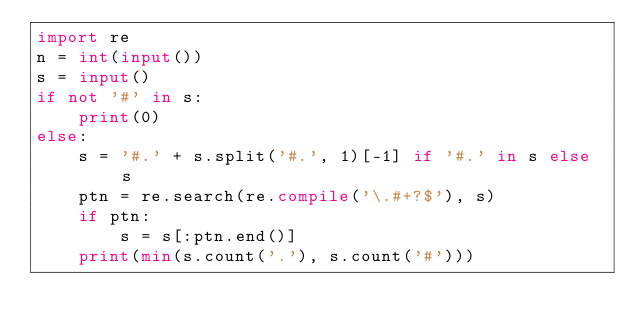Convert code to text. <code><loc_0><loc_0><loc_500><loc_500><_Python_>import re
n = int(input())
s = input()
if not '#' in s:
    print(0)
else:
    s = '#.' + s.split('#.', 1)[-1] if '#.' in s else  s
    ptn = re.search(re.compile('\.#+?$'), s)
    if ptn:
        s = s[:ptn.end()]
    print(min(s.count('.'), s.count('#')))</code> 